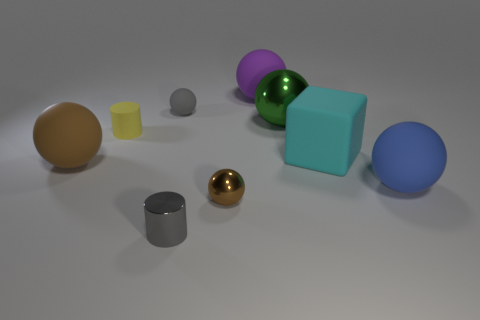Subtract all blue balls. How many balls are left? 5 Subtract 5 balls. How many balls are left? 1 Subtract all purple spheres. How many spheres are left? 5 Subtract 0 blue cylinders. How many objects are left? 9 Subtract all blocks. How many objects are left? 8 Subtract all red cubes. Subtract all green cylinders. How many cubes are left? 1 Subtract all purple cylinders. How many brown spheres are left? 2 Subtract all large blue matte things. Subtract all tiny cyan shiny objects. How many objects are left? 8 Add 4 green metal balls. How many green metal balls are left? 5 Add 8 tiny brown objects. How many tiny brown objects exist? 9 